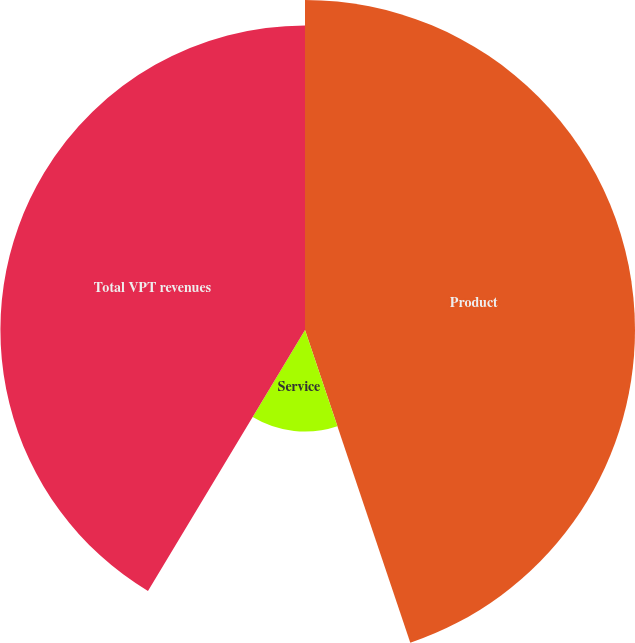Convert chart. <chart><loc_0><loc_0><loc_500><loc_500><pie_chart><fcel>Product<fcel>Service<fcel>Total VPT revenues<nl><fcel>44.83%<fcel>13.79%<fcel>41.38%<nl></chart> 